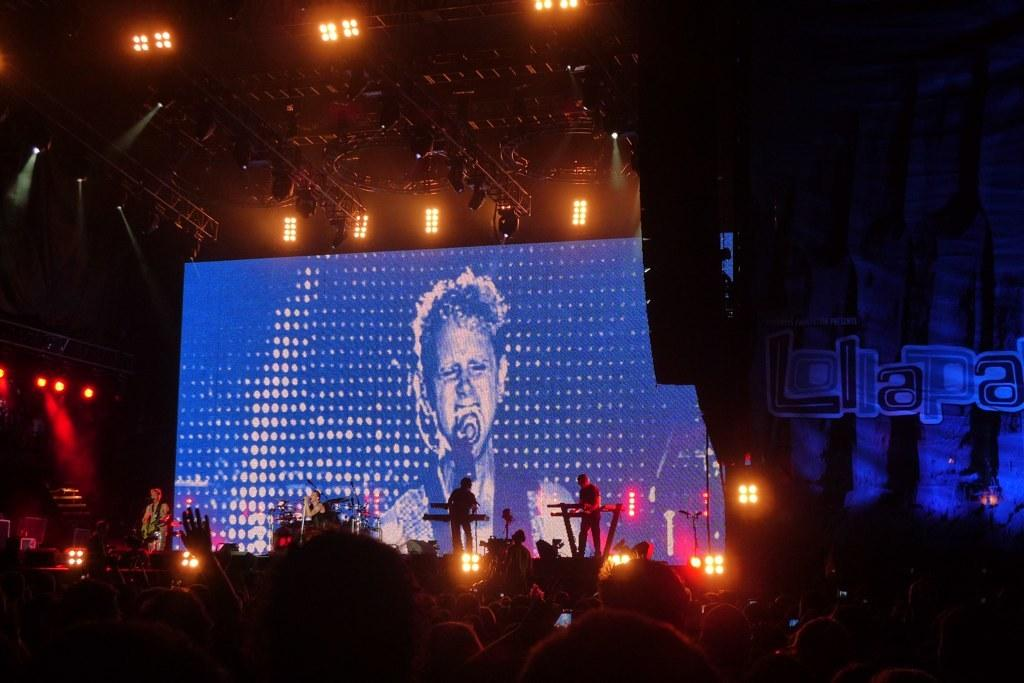What are the people in the image doing? The people in the image are playing musical instruments. Where are the people playing their instruments? They are on a dais. What can be seen in the background of the image? There is a screen and people visible in the background. What else can be observed in the image? There are lights present. What type of fear is the man experiencing in the image? There is no man present in the image, and therefore no fear can be observed. How many steps are visible in the image? There is no reference to steps in the image, so it is not possible to determine how many steps might be visible. 